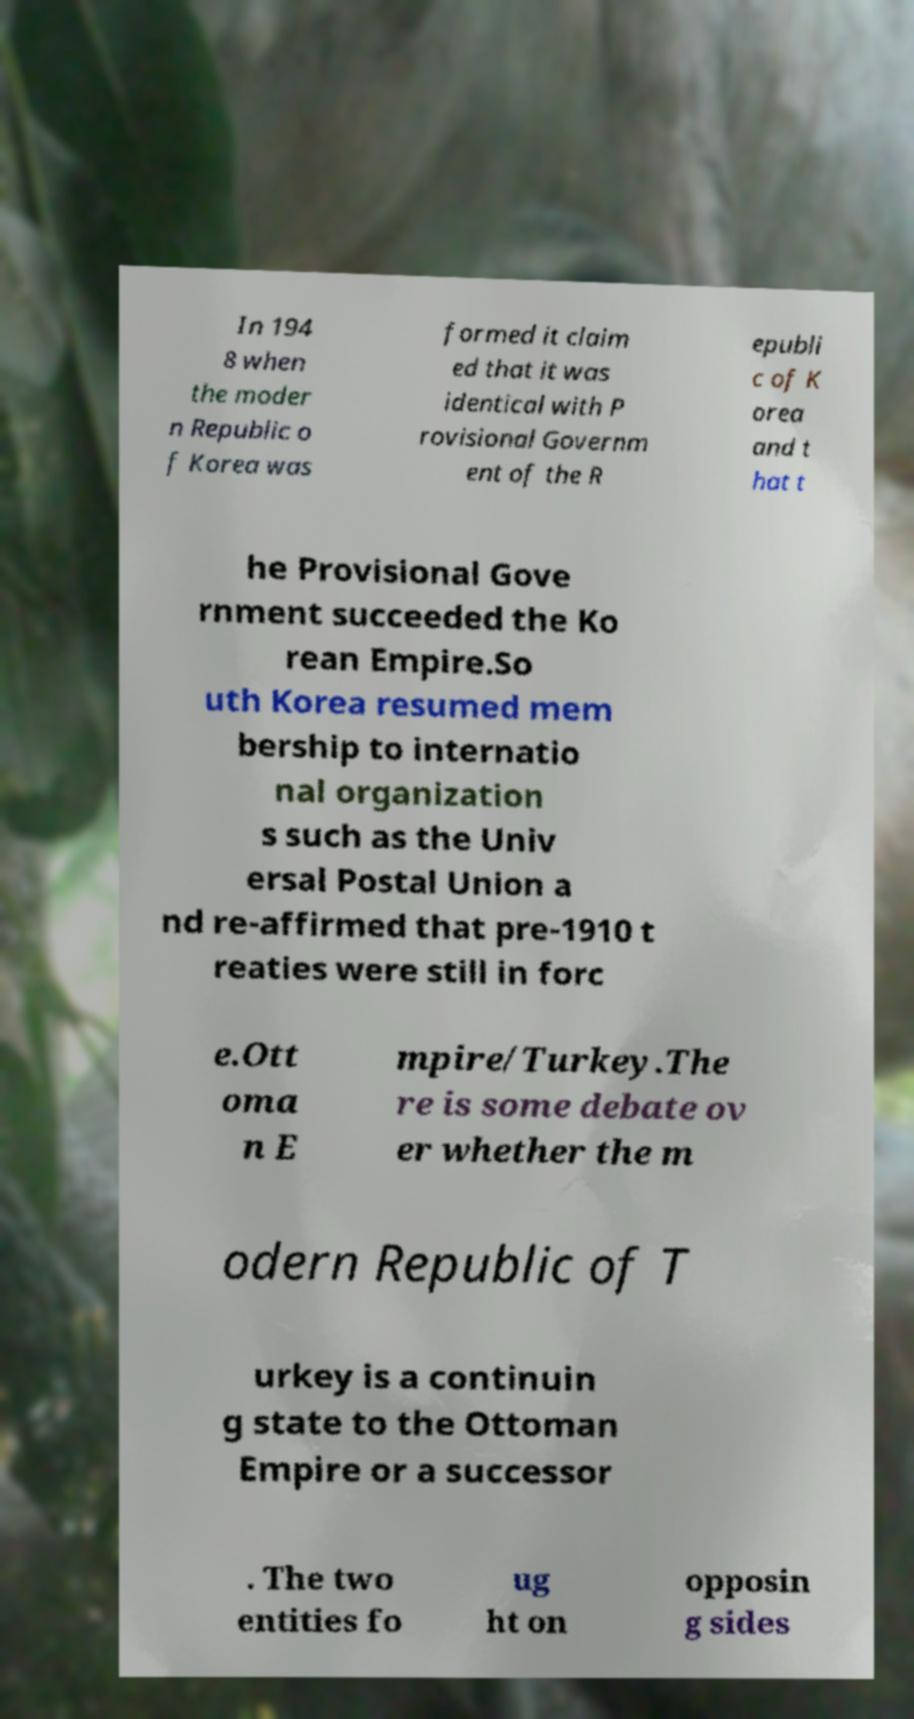Please identify and transcribe the text found in this image. In 194 8 when the moder n Republic o f Korea was formed it claim ed that it was identical with P rovisional Governm ent of the R epubli c of K orea and t hat t he Provisional Gove rnment succeeded the Ko rean Empire.So uth Korea resumed mem bership to internatio nal organization s such as the Univ ersal Postal Union a nd re-affirmed that pre-1910 t reaties were still in forc e.Ott oma n E mpire/Turkey.The re is some debate ov er whether the m odern Republic of T urkey is a continuin g state to the Ottoman Empire or a successor . The two entities fo ug ht on opposin g sides 